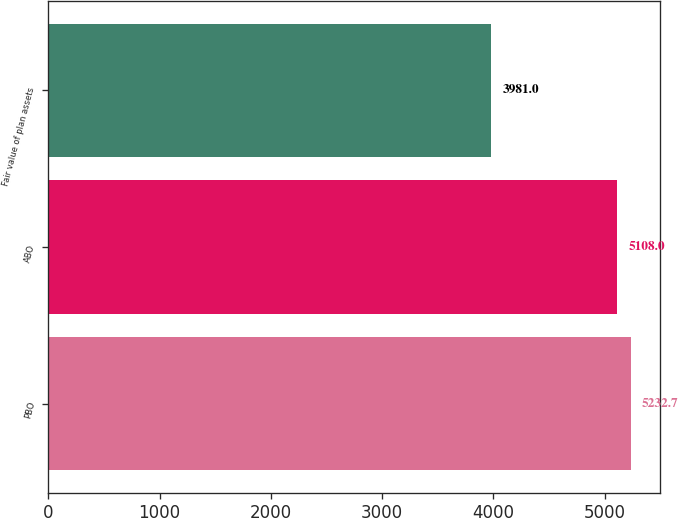Convert chart. <chart><loc_0><loc_0><loc_500><loc_500><bar_chart><fcel>PBO<fcel>ABO<fcel>Fair value of plan assets<nl><fcel>5232.7<fcel>5108<fcel>3981<nl></chart> 